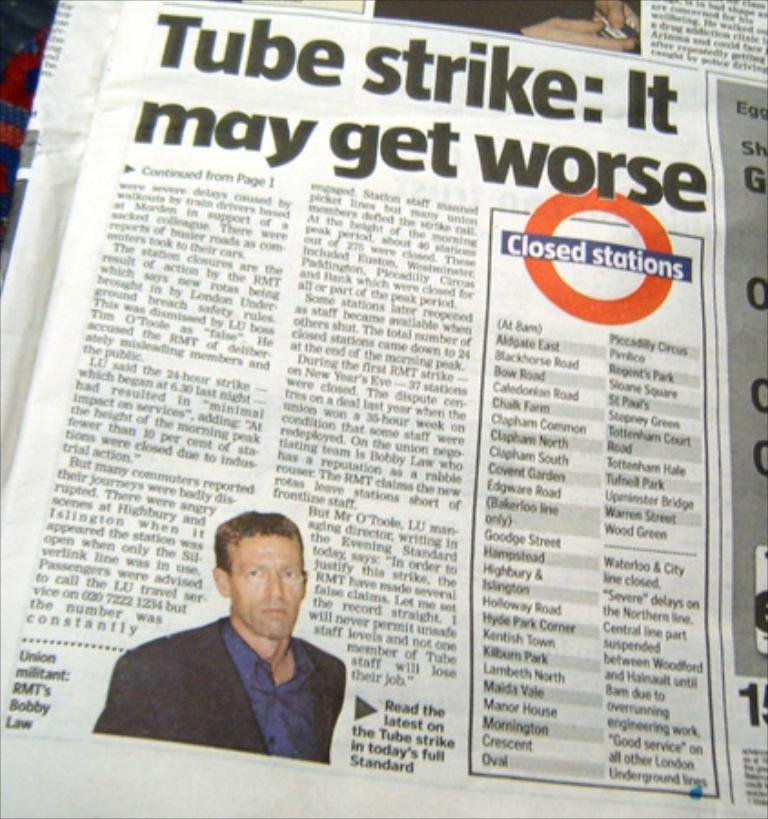<image>
Describe the image concisely. A newspaper article titled "Tube strike: It may get worse" contains a listing of closed stations. 